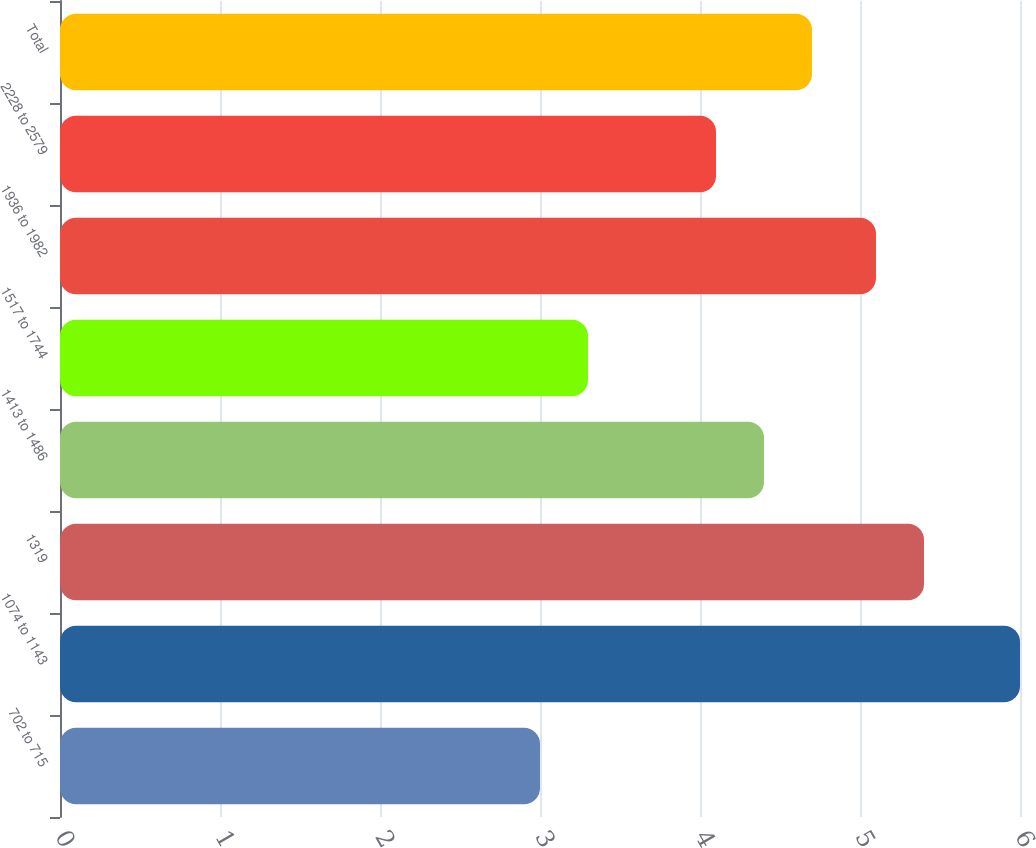Convert chart to OTSL. <chart><loc_0><loc_0><loc_500><loc_500><bar_chart><fcel>702 to 715<fcel>1074 to 1143<fcel>1319<fcel>1413 to 1486<fcel>1517 to 1744<fcel>1936 to 1982<fcel>2228 to 2579<fcel>Total<nl><fcel>3<fcel>6<fcel>5.4<fcel>4.4<fcel>3.3<fcel>5.1<fcel>4.1<fcel>4.7<nl></chart> 